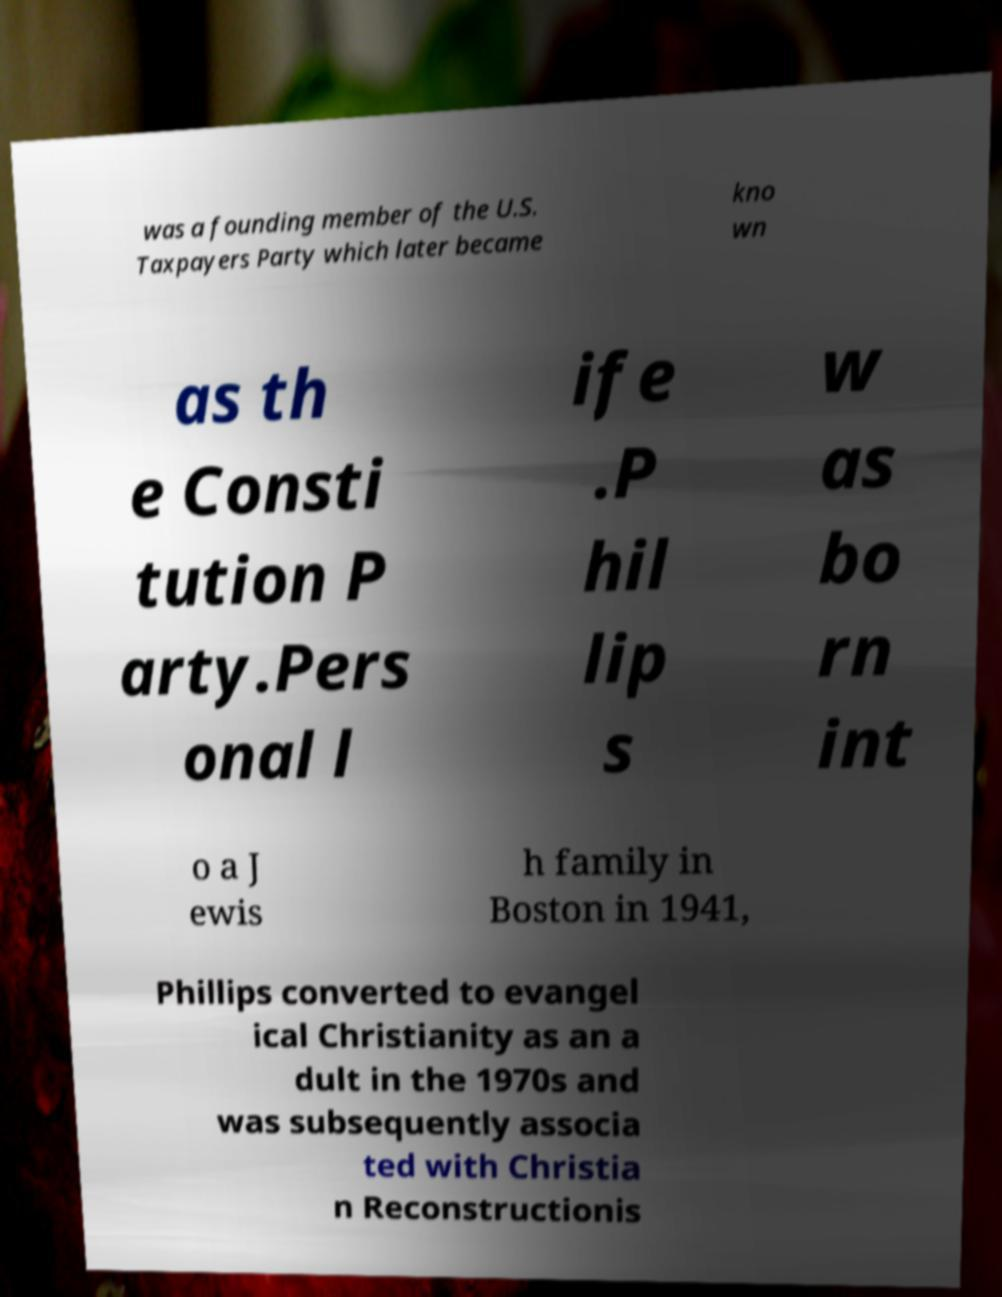Could you extract and type out the text from this image? was a founding member of the U.S. Taxpayers Party which later became kno wn as th e Consti tution P arty.Pers onal l ife .P hil lip s w as bo rn int o a J ewis h family in Boston in 1941, Phillips converted to evangel ical Christianity as an a dult in the 1970s and was subsequently associa ted with Christia n Reconstructionis 